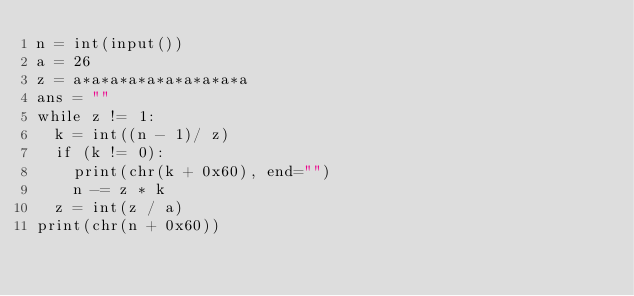Convert code to text. <code><loc_0><loc_0><loc_500><loc_500><_Python_>n = int(input())
a = 26
z = a*a*a*a*a*a*a*a*a*a
ans = ""
while z != 1:
  k = int((n - 1)/ z)
  if (k != 0):
    print(chr(k + 0x60), end="")
    n -= z * k
  z = int(z / a)
print(chr(n + 0x60))</code> 